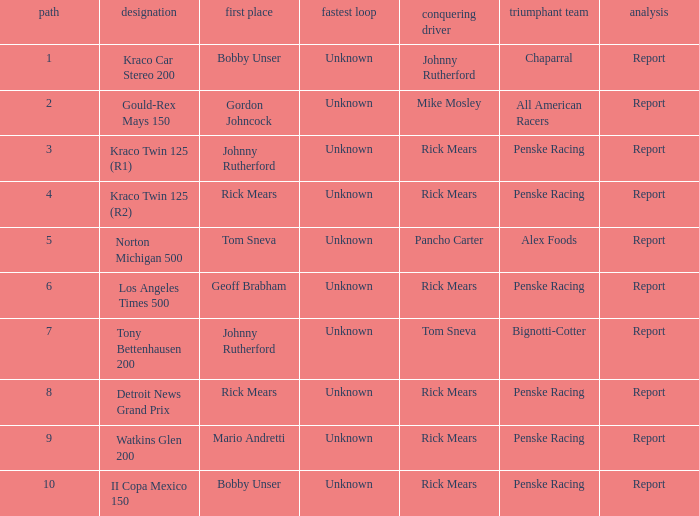The race tony bettenhausen 200 has what smallest rd? 7.0. 